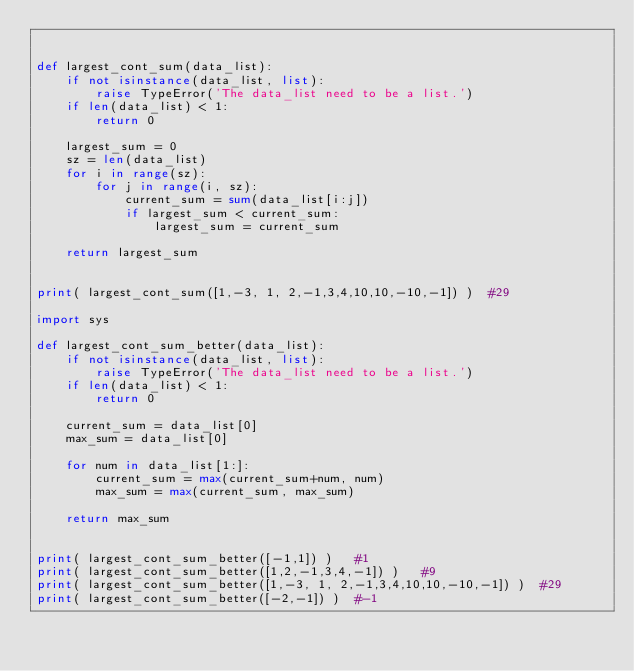Convert code to text. <code><loc_0><loc_0><loc_500><loc_500><_Python_>

def largest_cont_sum(data_list):
    if not isinstance(data_list, list):
        raise TypeError('The data_list need to be a list.')
    if len(data_list) < 1:
        return 0

    largest_sum = 0
    sz = len(data_list)
    for i in range(sz):
        for j in range(i, sz):
            current_sum = sum(data_list[i:j])
            if largest_sum < current_sum:
                largest_sum = current_sum

    return largest_sum


print( largest_cont_sum([1,-3, 1, 2,-1,3,4,10,10,-10,-1]) )  #29

import sys

def largest_cont_sum_better(data_list):
    if not isinstance(data_list, list):
        raise TypeError('The data_list need to be a list.')
    if len(data_list) < 1:
        return 0

    current_sum = data_list[0]
    max_sum = data_list[0]

    for num in data_list[1:]:
        current_sum = max(current_sum+num, num)
        max_sum = max(current_sum, max_sum)

    return max_sum


print( largest_cont_sum_better([-1,1]) )   #1
print( largest_cont_sum_better([1,2,-1,3,4,-1]) )   #9
print( largest_cont_sum_better([1,-3, 1, 2,-1,3,4,10,10,-10,-1]) )  #29
print( largest_cont_sum_better([-2,-1]) )  #-1
</code> 